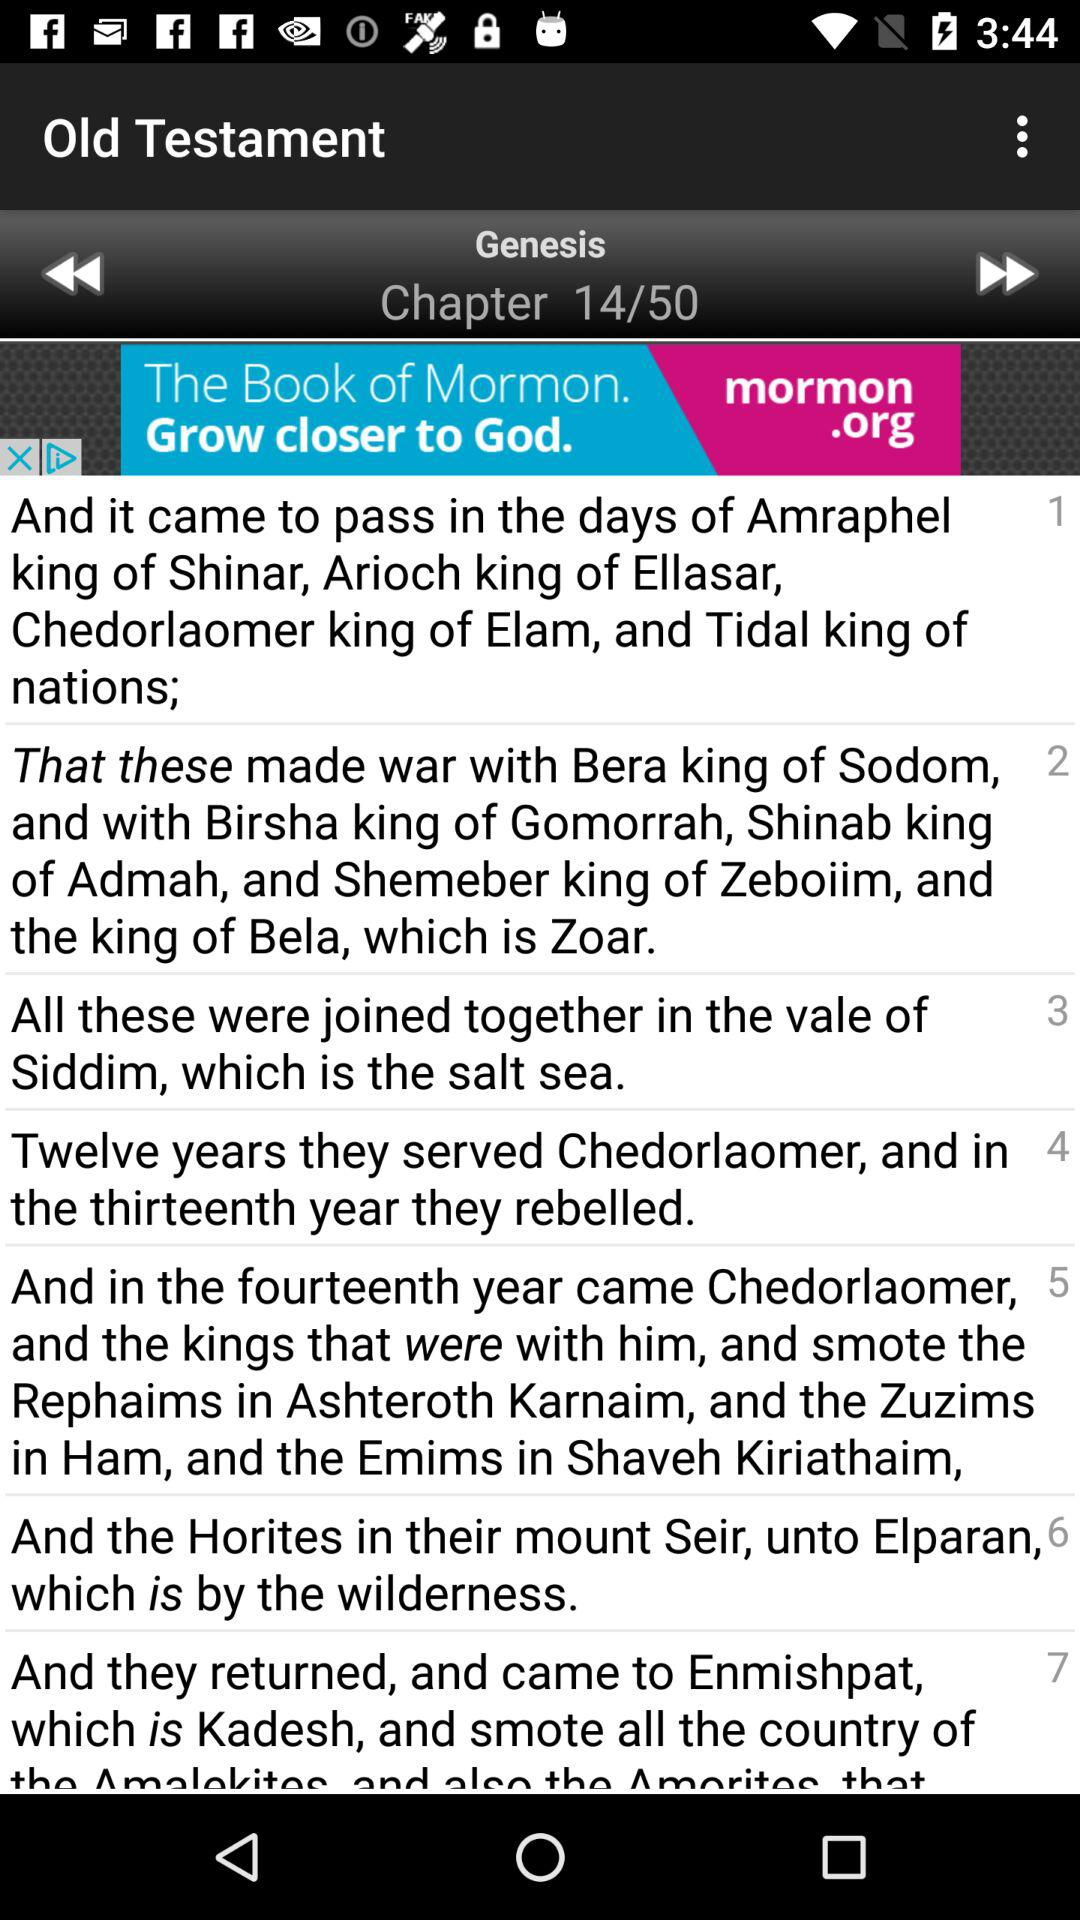How many verses are there in Genesis chapter 14?
Answer the question using a single word or phrase. 7 